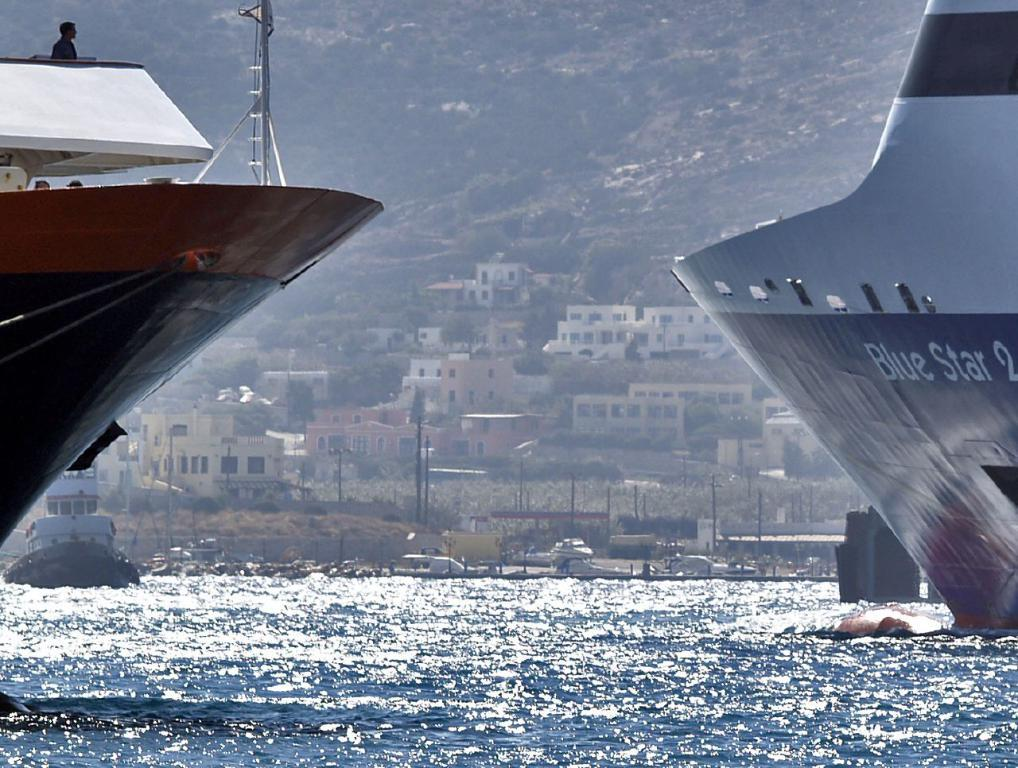<image>
Describe the image concisely. Two giant boats are passing each other and one says Blue Star 2. 